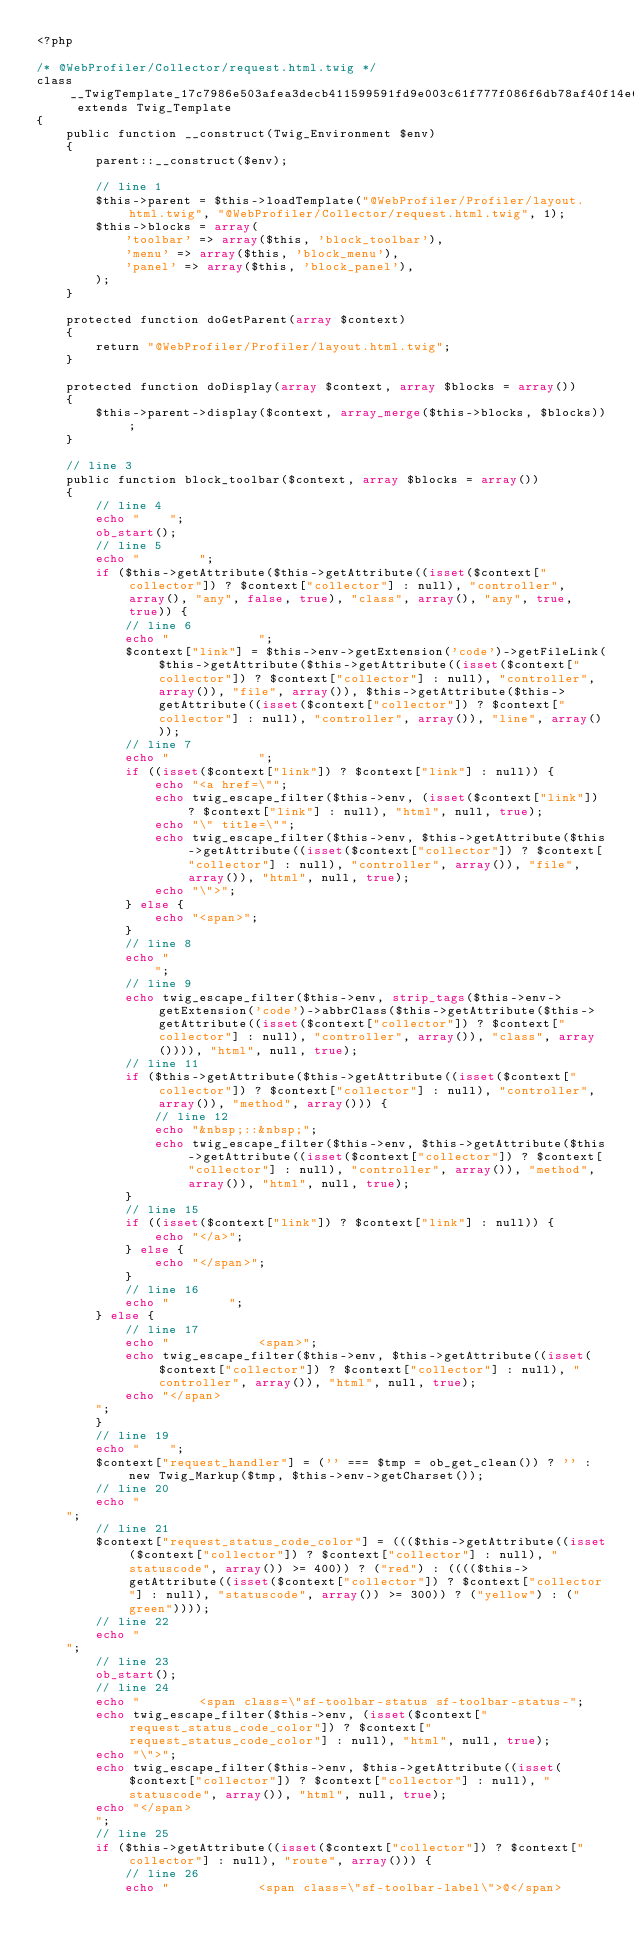<code> <loc_0><loc_0><loc_500><loc_500><_PHP_><?php

/* @WebProfiler/Collector/request.html.twig */
class __TwigTemplate_17c7986e503afea3decb411599591fd9e003c61f777f086f6db78af40f14e696 extends Twig_Template
{
    public function __construct(Twig_Environment $env)
    {
        parent::__construct($env);

        // line 1
        $this->parent = $this->loadTemplate("@WebProfiler/Profiler/layout.html.twig", "@WebProfiler/Collector/request.html.twig", 1);
        $this->blocks = array(
            'toolbar' => array($this, 'block_toolbar'),
            'menu' => array($this, 'block_menu'),
            'panel' => array($this, 'block_panel'),
        );
    }

    protected function doGetParent(array $context)
    {
        return "@WebProfiler/Profiler/layout.html.twig";
    }

    protected function doDisplay(array $context, array $blocks = array())
    {
        $this->parent->display($context, array_merge($this->blocks, $blocks));
    }

    // line 3
    public function block_toolbar($context, array $blocks = array())
    {
        // line 4
        echo "    ";
        ob_start();
        // line 5
        echo "        ";
        if ($this->getAttribute($this->getAttribute((isset($context["collector"]) ? $context["collector"] : null), "controller", array(), "any", false, true), "class", array(), "any", true, true)) {
            // line 6
            echo "            ";
            $context["link"] = $this->env->getExtension('code')->getFileLink($this->getAttribute($this->getAttribute((isset($context["collector"]) ? $context["collector"] : null), "controller", array()), "file", array()), $this->getAttribute($this->getAttribute((isset($context["collector"]) ? $context["collector"] : null), "controller", array()), "line", array()));
            // line 7
            echo "            ";
            if ((isset($context["link"]) ? $context["link"] : null)) {
                echo "<a href=\"";
                echo twig_escape_filter($this->env, (isset($context["link"]) ? $context["link"] : null), "html", null, true);
                echo "\" title=\"";
                echo twig_escape_filter($this->env, $this->getAttribute($this->getAttribute((isset($context["collector"]) ? $context["collector"] : null), "controller", array()), "file", array()), "html", null, true);
                echo "\">";
            } else {
                echo "<span>";
            }
            // line 8
            echo "
                ";
            // line 9
            echo twig_escape_filter($this->env, strip_tags($this->env->getExtension('code')->abbrClass($this->getAttribute($this->getAttribute((isset($context["collector"]) ? $context["collector"] : null), "controller", array()), "class", array()))), "html", null, true);
            // line 11
            if ($this->getAttribute($this->getAttribute((isset($context["collector"]) ? $context["collector"] : null), "controller", array()), "method", array())) {
                // line 12
                echo "&nbsp;::&nbsp;";
                echo twig_escape_filter($this->env, $this->getAttribute($this->getAttribute((isset($context["collector"]) ? $context["collector"] : null), "controller", array()), "method", array()), "html", null, true);
            }
            // line 15
            if ((isset($context["link"]) ? $context["link"] : null)) {
                echo "</a>";
            } else {
                echo "</span>";
            }
            // line 16
            echo "        ";
        } else {
            // line 17
            echo "            <span>";
            echo twig_escape_filter($this->env, $this->getAttribute((isset($context["collector"]) ? $context["collector"] : null), "controller", array()), "html", null, true);
            echo "</span>
        ";
        }
        // line 19
        echo "    ";
        $context["request_handler"] = ('' === $tmp = ob_get_clean()) ? '' : new Twig_Markup($tmp, $this->env->getCharset());
        // line 20
        echo "
    ";
        // line 21
        $context["request_status_code_color"] = ((($this->getAttribute((isset($context["collector"]) ? $context["collector"] : null), "statuscode", array()) >= 400)) ? ("red") : (((($this->getAttribute((isset($context["collector"]) ? $context["collector"] : null), "statuscode", array()) >= 300)) ? ("yellow") : ("green"))));
        // line 22
        echo "
    ";
        // line 23
        ob_start();
        // line 24
        echo "        <span class=\"sf-toolbar-status sf-toolbar-status-";
        echo twig_escape_filter($this->env, (isset($context["request_status_code_color"]) ? $context["request_status_code_color"] : null), "html", null, true);
        echo "\">";
        echo twig_escape_filter($this->env, $this->getAttribute((isset($context["collector"]) ? $context["collector"] : null), "statuscode", array()), "html", null, true);
        echo "</span>
        ";
        // line 25
        if ($this->getAttribute((isset($context["collector"]) ? $context["collector"] : null), "route", array())) {
            // line 26
            echo "            <span class=\"sf-toolbar-label\">@</span></code> 